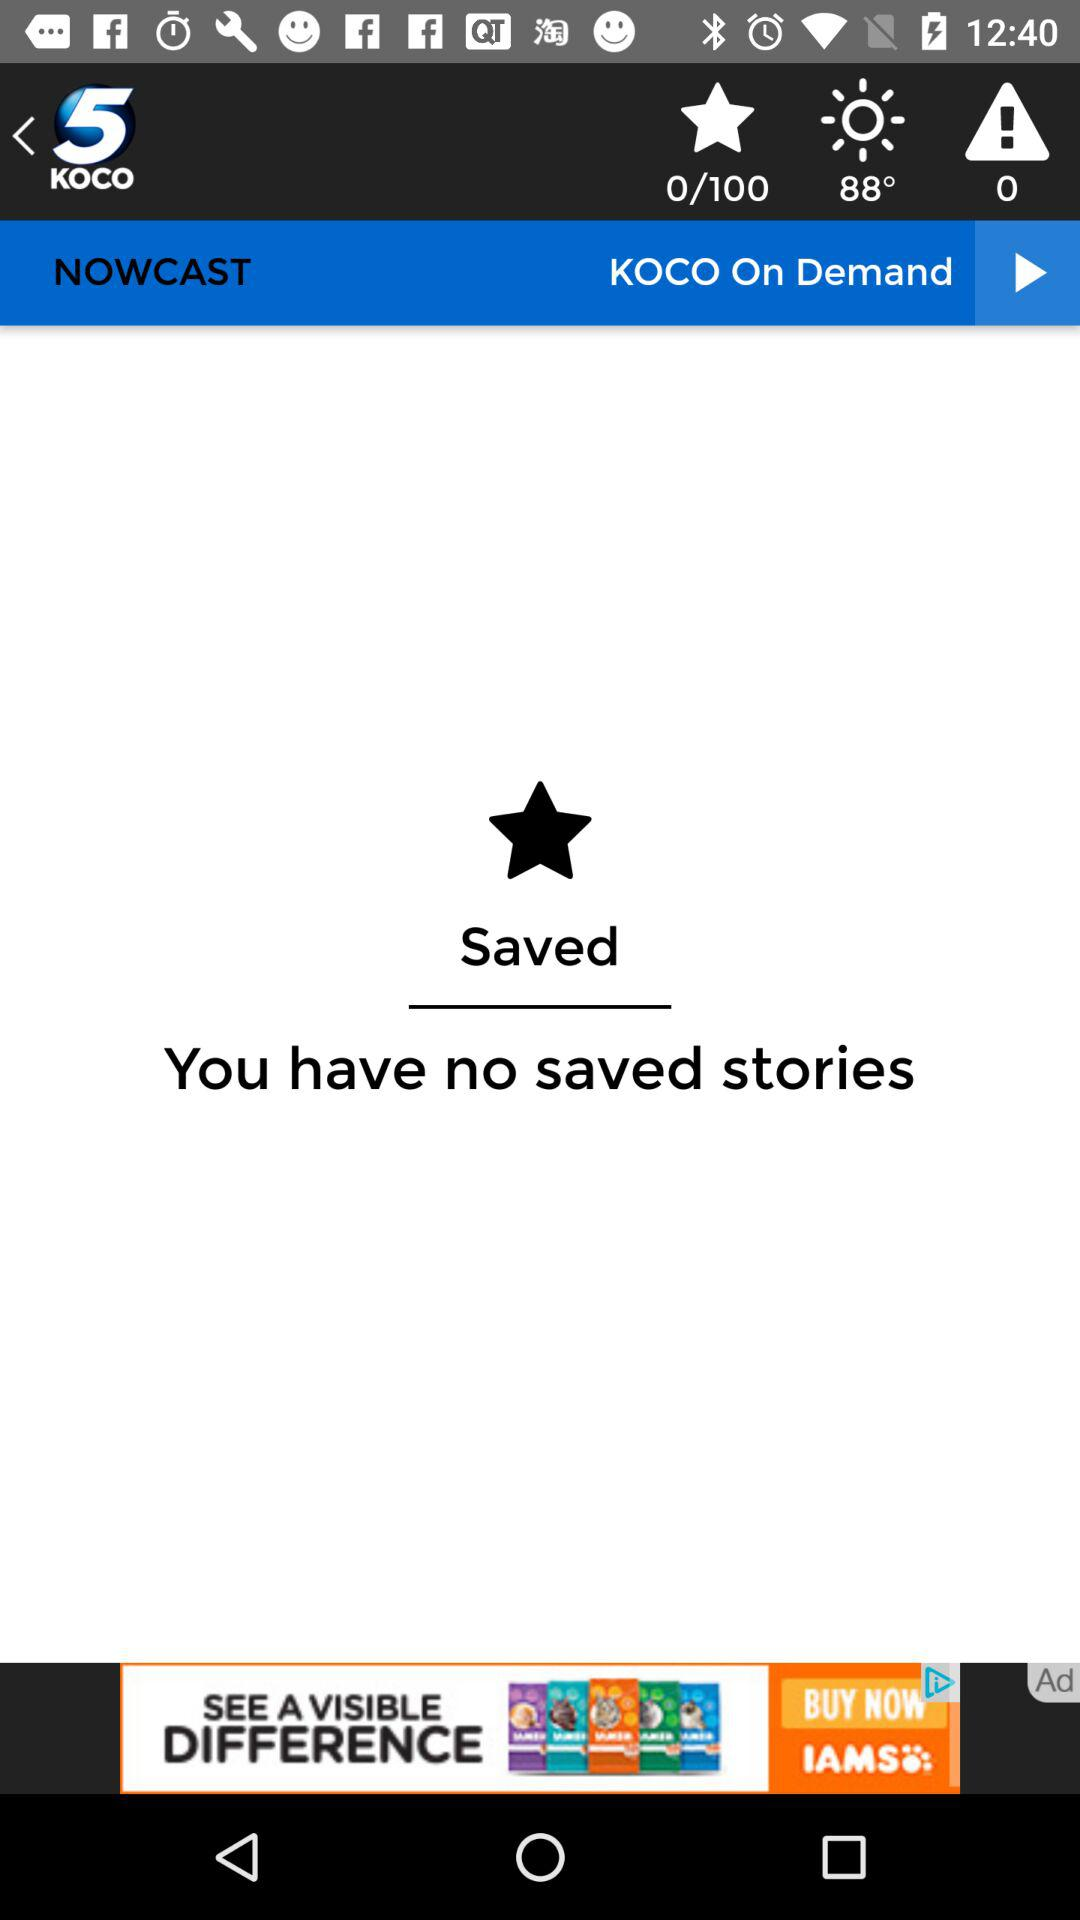What is the temperature showing? The temperature is 88°. 